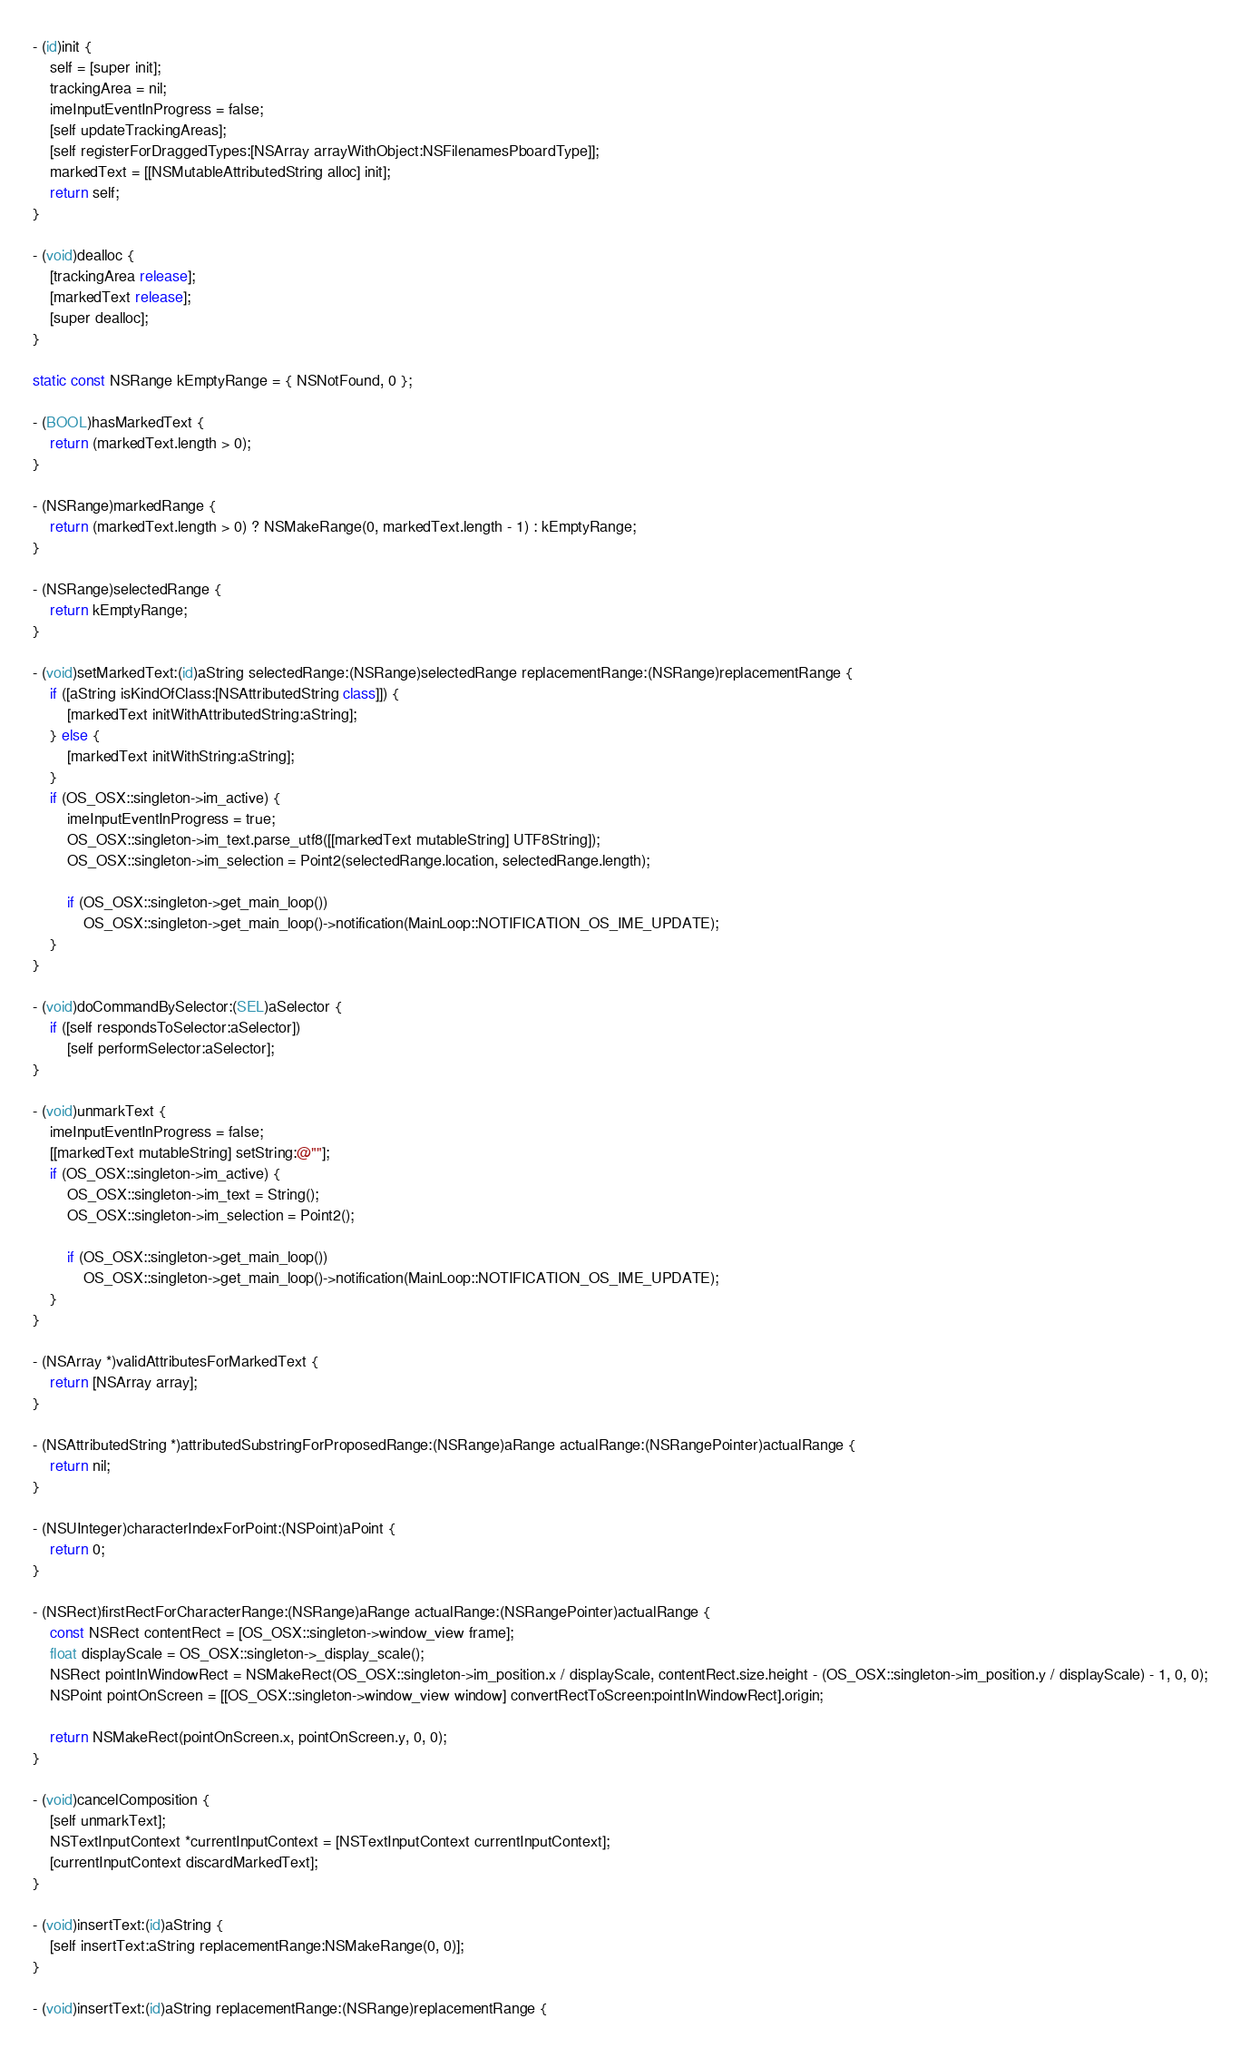Convert code to text. <code><loc_0><loc_0><loc_500><loc_500><_ObjectiveC_>
- (id)init {
	self = [super init];
	trackingArea = nil;
	imeInputEventInProgress = false;
	[self updateTrackingAreas];
	[self registerForDraggedTypes:[NSArray arrayWithObject:NSFilenamesPboardType]];
	markedText = [[NSMutableAttributedString alloc] init];
	return self;
}

- (void)dealloc {
	[trackingArea release];
	[markedText release];
	[super dealloc];
}

static const NSRange kEmptyRange = { NSNotFound, 0 };

- (BOOL)hasMarkedText {
	return (markedText.length > 0);
}

- (NSRange)markedRange {
	return (markedText.length > 0) ? NSMakeRange(0, markedText.length - 1) : kEmptyRange;
}

- (NSRange)selectedRange {
	return kEmptyRange;
}

- (void)setMarkedText:(id)aString selectedRange:(NSRange)selectedRange replacementRange:(NSRange)replacementRange {
	if ([aString isKindOfClass:[NSAttributedString class]]) {
		[markedText initWithAttributedString:aString];
	} else {
		[markedText initWithString:aString];
	}
	if (OS_OSX::singleton->im_active) {
		imeInputEventInProgress = true;
		OS_OSX::singleton->im_text.parse_utf8([[markedText mutableString] UTF8String]);
		OS_OSX::singleton->im_selection = Point2(selectedRange.location, selectedRange.length);

		if (OS_OSX::singleton->get_main_loop())
			OS_OSX::singleton->get_main_loop()->notification(MainLoop::NOTIFICATION_OS_IME_UPDATE);
	}
}

- (void)doCommandBySelector:(SEL)aSelector {
	if ([self respondsToSelector:aSelector])
		[self performSelector:aSelector];
}

- (void)unmarkText {
	imeInputEventInProgress = false;
	[[markedText mutableString] setString:@""];
	if (OS_OSX::singleton->im_active) {
		OS_OSX::singleton->im_text = String();
		OS_OSX::singleton->im_selection = Point2();

		if (OS_OSX::singleton->get_main_loop())
			OS_OSX::singleton->get_main_loop()->notification(MainLoop::NOTIFICATION_OS_IME_UPDATE);
	}
}

- (NSArray *)validAttributesForMarkedText {
	return [NSArray array];
}

- (NSAttributedString *)attributedSubstringForProposedRange:(NSRange)aRange actualRange:(NSRangePointer)actualRange {
	return nil;
}

- (NSUInteger)characterIndexForPoint:(NSPoint)aPoint {
	return 0;
}

- (NSRect)firstRectForCharacterRange:(NSRange)aRange actualRange:(NSRangePointer)actualRange {
	const NSRect contentRect = [OS_OSX::singleton->window_view frame];
	float displayScale = OS_OSX::singleton->_display_scale();
	NSRect pointInWindowRect = NSMakeRect(OS_OSX::singleton->im_position.x / displayScale, contentRect.size.height - (OS_OSX::singleton->im_position.y / displayScale) - 1, 0, 0);
	NSPoint pointOnScreen = [[OS_OSX::singleton->window_view window] convertRectToScreen:pointInWindowRect].origin;

	return NSMakeRect(pointOnScreen.x, pointOnScreen.y, 0, 0);
}

- (void)cancelComposition {
	[self unmarkText];
	NSTextInputContext *currentInputContext = [NSTextInputContext currentInputContext];
	[currentInputContext discardMarkedText];
}

- (void)insertText:(id)aString {
	[self insertText:aString replacementRange:NSMakeRange(0, 0)];
}

- (void)insertText:(id)aString replacementRange:(NSRange)replacementRange {</code> 